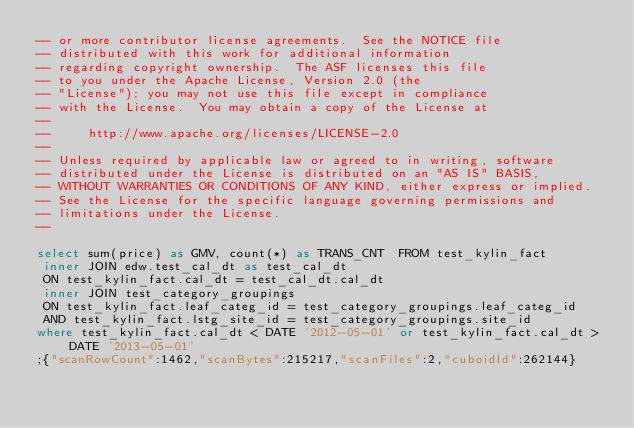Convert code to text. <code><loc_0><loc_0><loc_500><loc_500><_SQL_>-- or more contributor license agreements.  See the NOTICE file
-- distributed with this work for additional information
-- regarding copyright ownership.  The ASF licenses this file
-- to you under the Apache License, Version 2.0 (the
-- "License"); you may not use this file except in compliance
-- with the License.  You may obtain a copy of the License at
--
--     http://www.apache.org/licenses/LICENSE-2.0
--
-- Unless required by applicable law or agreed to in writing, software
-- distributed under the License is distributed on an "AS IS" BASIS,
-- WITHOUT WARRANTIES OR CONDITIONS OF ANY KIND, either express or implied.
-- See the License for the specific language governing permissions and
-- limitations under the License.
--

select sum(price) as GMV, count(*) as TRANS_CNT  FROM test_kylin_fact
 inner JOIN edw.test_cal_dt as test_cal_dt
 ON test_kylin_fact.cal_dt = test_cal_dt.cal_dt
 inner JOIN test_category_groupings
 ON test_kylin_fact.leaf_categ_id = test_category_groupings.leaf_categ_id
 AND test_kylin_fact.lstg_site_id = test_category_groupings.site_id
where test_kylin_fact.cal_dt < DATE '2012-05-01' or test_kylin_fact.cal_dt > DATE '2013-05-01'
;{"scanRowCount":1462,"scanBytes":215217,"scanFiles":2,"cuboidId":262144}</code> 